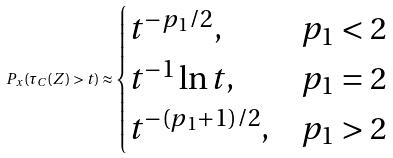Convert formula to latex. <formula><loc_0><loc_0><loc_500><loc_500>P _ { x } ( \tau _ { C } ( Z ) > t ) \approx \begin{cases} t ^ { - p _ { 1 } / 2 } , & \text {$p_{1}<2$} \\ t ^ { - 1 } \ln t , & \text {$p_{1}=2$} \\ t ^ { - ( p _ { 1 } + 1 ) / 2 } , & \text {$p_{1}>2$} \end{cases}</formula> 